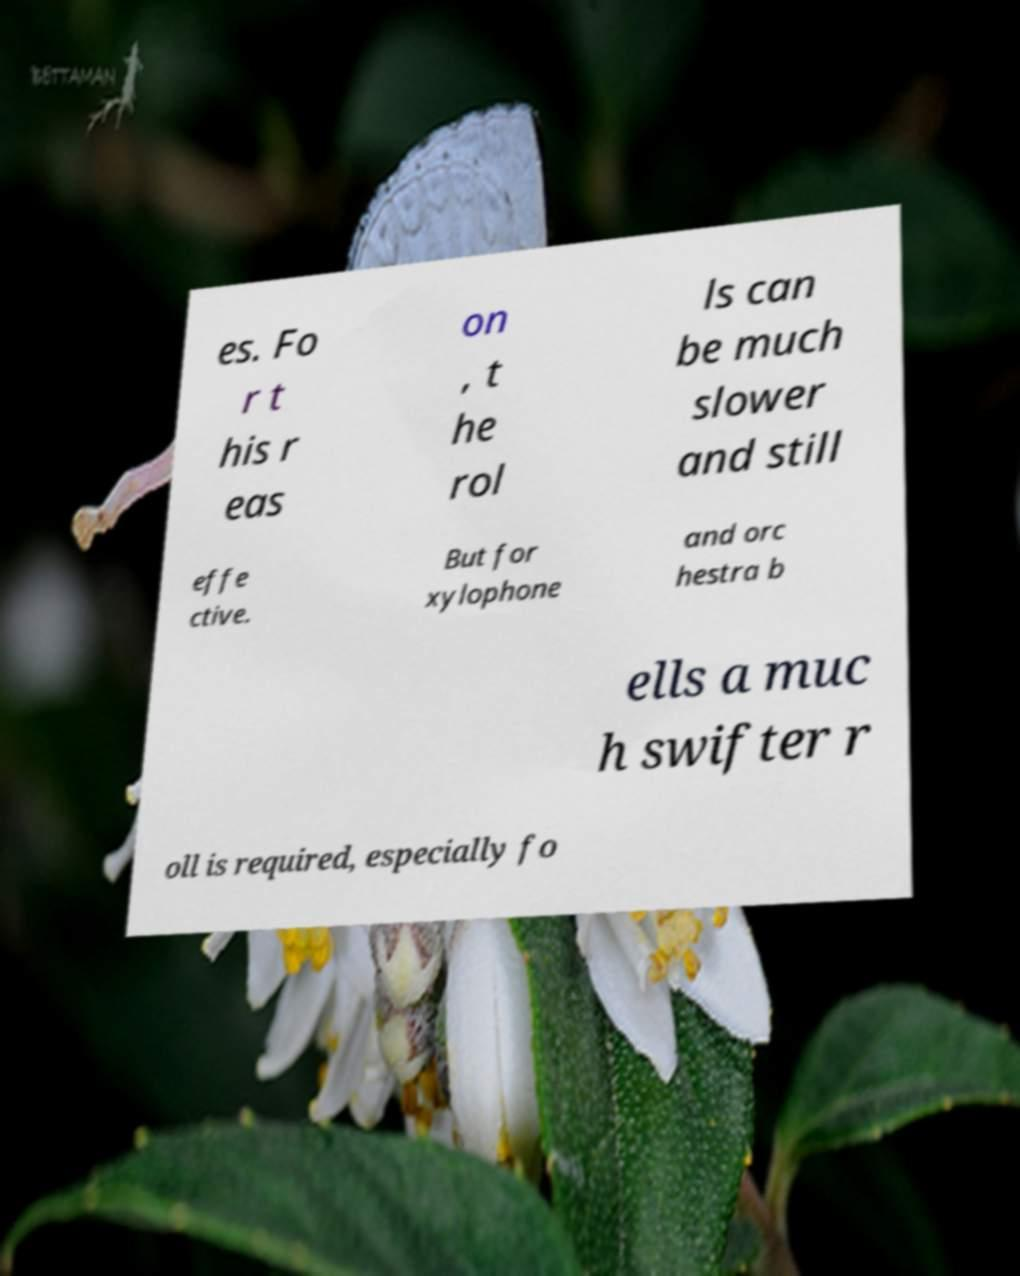There's text embedded in this image that I need extracted. Can you transcribe it verbatim? es. Fo r t his r eas on , t he rol ls can be much slower and still effe ctive. But for xylophone and orc hestra b ells a muc h swifter r oll is required, especially fo 